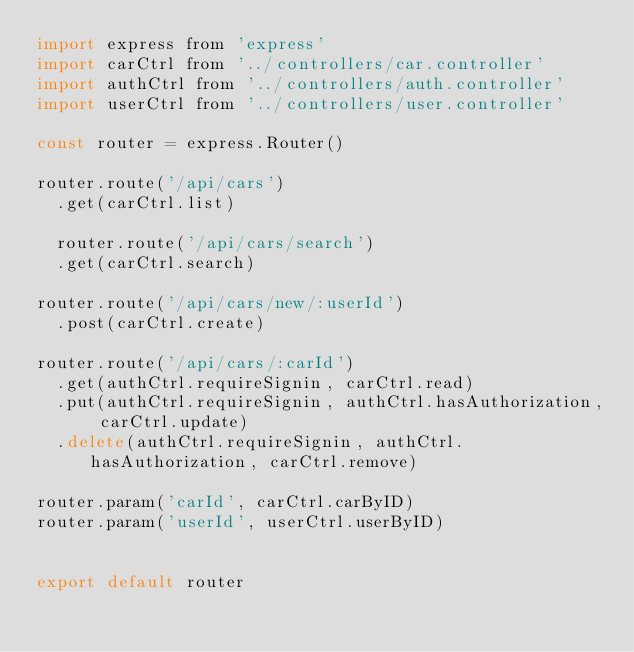Convert code to text. <code><loc_0><loc_0><loc_500><loc_500><_JavaScript_>import express from 'express'
import carCtrl from '../controllers/car.controller'
import authCtrl from '../controllers/auth.controller'
import userCtrl from '../controllers/user.controller'

const router = express.Router()

router.route('/api/cars')
  .get(carCtrl.list)

  router.route('/api/cars/search')
  .get(carCtrl.search)

router.route('/api/cars/new/:userId')
  .post(carCtrl.create)

router.route('/api/cars/:carId')
  .get(authCtrl.requireSignin, carCtrl.read)
  .put(authCtrl.requireSignin, authCtrl.hasAuthorization, carCtrl.update)
  .delete(authCtrl.requireSignin, authCtrl.hasAuthorization, carCtrl.remove)

router.param('carId', carCtrl.carByID)
router.param('userId', userCtrl.userByID)


export default router
</code> 